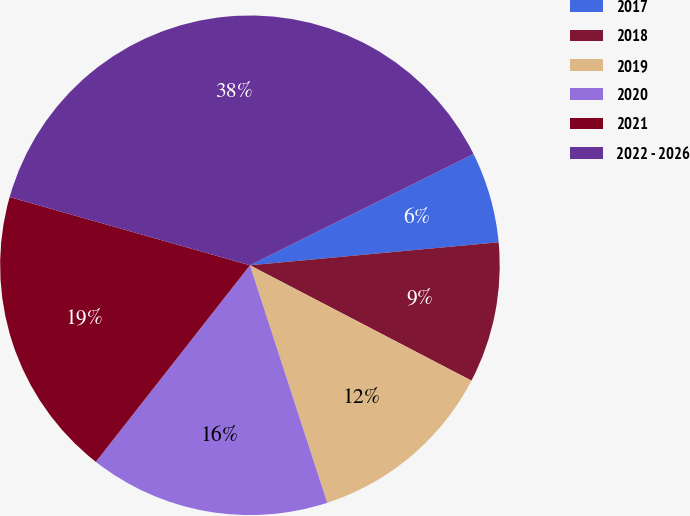Convert chart to OTSL. <chart><loc_0><loc_0><loc_500><loc_500><pie_chart><fcel>2017<fcel>2018<fcel>2019<fcel>2020<fcel>2021<fcel>2022 - 2026<nl><fcel>5.88%<fcel>9.11%<fcel>12.35%<fcel>15.59%<fcel>18.82%<fcel>38.25%<nl></chart> 